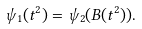Convert formula to latex. <formula><loc_0><loc_0><loc_500><loc_500>\psi _ { 1 } ( t ^ { 2 } ) = \psi _ { 2 } ( B ( t ^ { 2 } ) ) .</formula> 